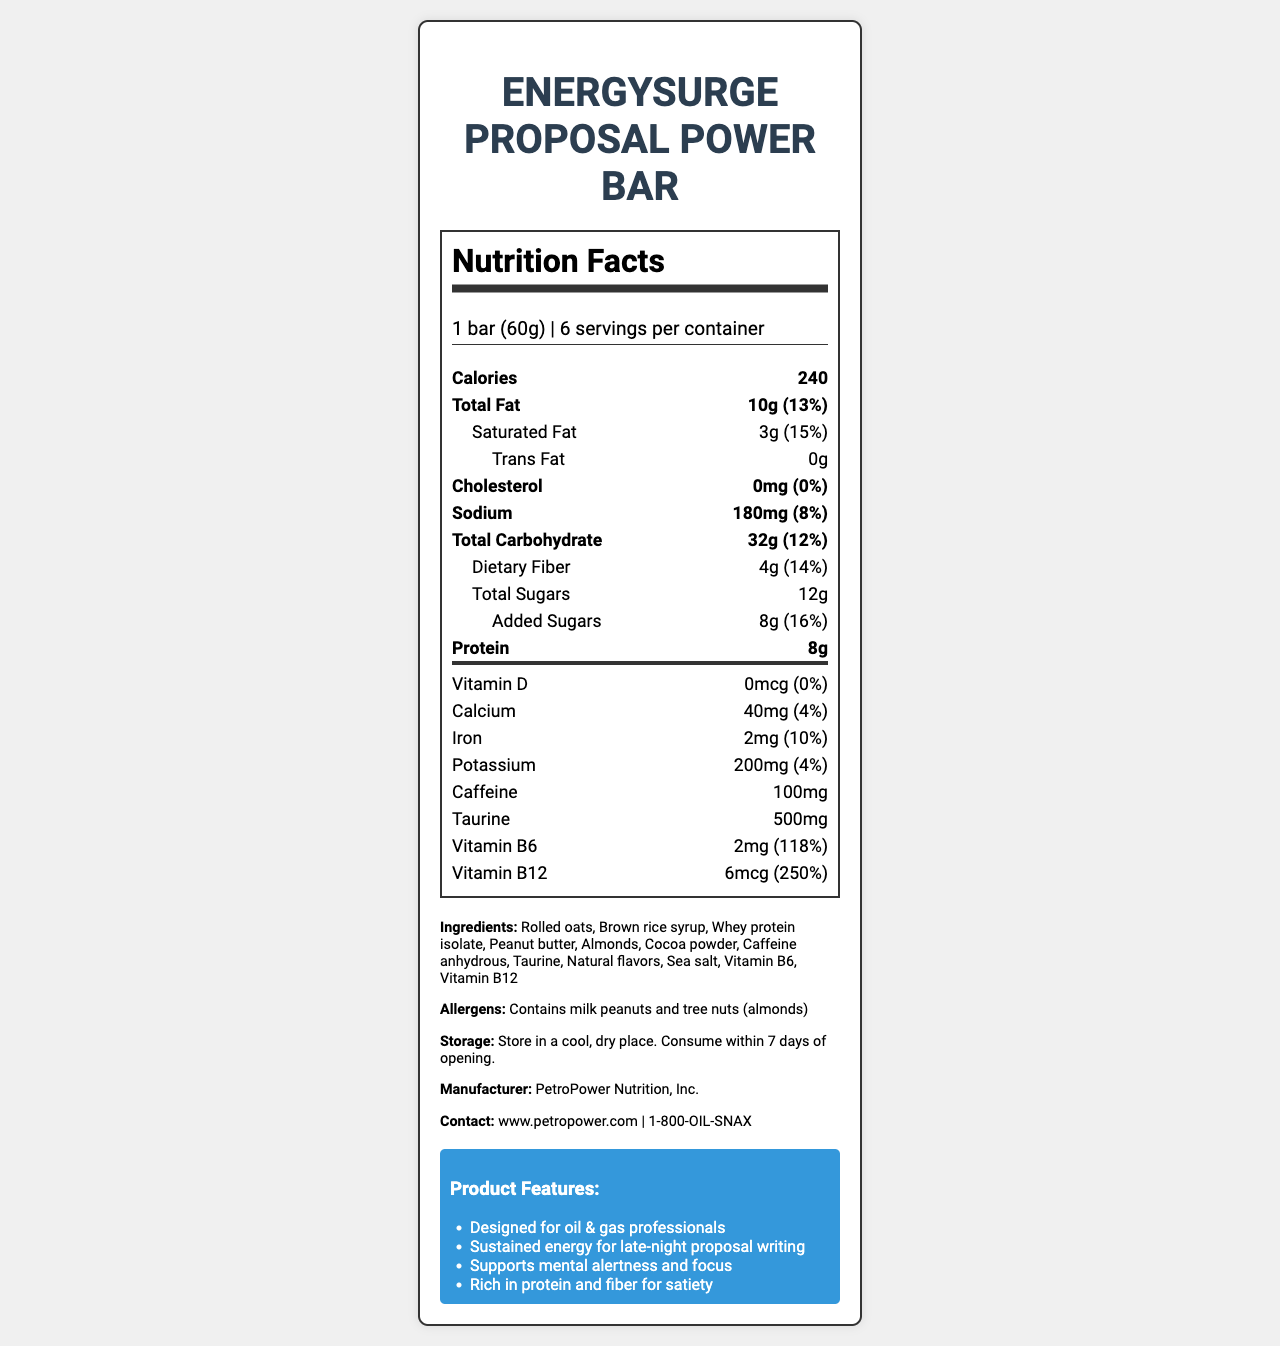what is the product name? The document title and header clearly state the product name as "EnergySurge Proposal Power Bar".
Answer: EnergySurge Proposal Power Bar what is the serving size? The serving size is mentioned in the "serving-info" section of the nutrition label.
Answer: 1 bar (60g) how many servings are in one container? The "serving-info" section indicates that there are 6 servings per container.
Answer: 6 servings what is the total amount of calories per serving? The bolded nutrient row for calories shows a total amount of 240 calories.
Answer: 240 calories what is the total fat content per serving? The total fat content per serving is listed in the bolded nutrient row for total fat.
Answer: 10g how much saturated fat is in one bar? The nutrient row indented under total fat lists the saturated fat content as 3g.
Answer: 3g does the product contain any trans fat? The double-indented nutrient row under total fat shows 0g of trans fat, indicating none is present.
Answer: No what is the main allergen information provided? The allergens section clearly states that the product contains milk, peanuts, and almonds.
Answer: Contains milk, peanuts, and tree nuts (almonds) what is the role of taurine in this snack bar? The document lists taurine as an ingredient but does not specify its role.
Answer: Not provided which vitamins are included in this product? A. Vitamin A and B12 B. Vitamin C and B6 C. Vitamin B6 and B12 D. Vitamin D and C The vitamins section highlights the presence of Vitamin B6 and B12.
Answer: C how much caffeine is included in this product? The nutrient row under the vitamins section specifically lists 100mg of caffeine.
Answer: 100mg what marketing claims are mentioned for the product? The marketing section lists several claims stating these benefits and target audience.
Answer: Designed for oil & gas professionals, Sustained energy for late-night proposal writing, Supports mental alertness and focus, Rich in protein and fiber for satiety what storage instructions are provided? A. Refrigerate after opening B. Store in a cool, dry place C. Do not freeze D. Store in direct sunlight The storage instructions section advises to "Store in a cool, dry place."
Answer: B is there any cholesterol in this product? The nutrient row for cholesterol indicates 0mg, which means there is no cholesterol.
Answer: No summarize the key nutritional and marketing information about the product. The document combines both nutritional facts and marketing claims that highlight the product’s benefits for professionals in the oil & gas industry requiring late-night energy and mental focus.
Answer: The EnergySurge Proposal Power Bar provides 240 calories per 60g serving. It contains 10g of total fat, 32g of total carbohydrates, and 8g of protein. It also includes essential vitamins B6 and B12, 100mg caffeine, and 500mg taurine, aimed at ensuring sustained energy and mental alertness. This snack bar is designed for oil & gas professionals who work late on proposals and need a boost in focus and satiety. Allergens include milk, peanuts, and almonds. 